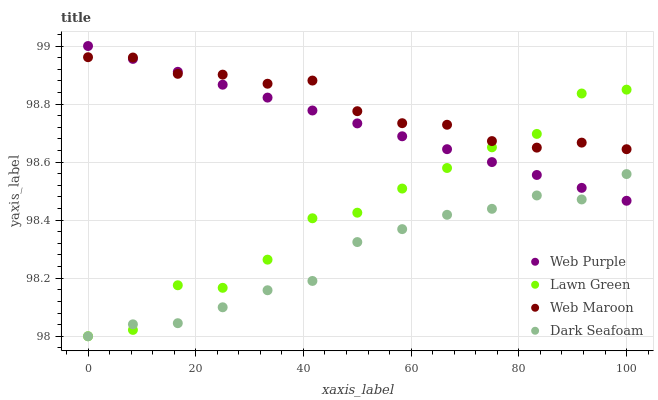Does Dark Seafoam have the minimum area under the curve?
Answer yes or no. Yes. Does Web Maroon have the maximum area under the curve?
Answer yes or no. Yes. Does Web Purple have the minimum area under the curve?
Answer yes or no. No. Does Web Purple have the maximum area under the curve?
Answer yes or no. No. Is Web Purple the smoothest?
Answer yes or no. Yes. Is Lawn Green the roughest?
Answer yes or no. Yes. Is Web Maroon the smoothest?
Answer yes or no. No. Is Web Maroon the roughest?
Answer yes or no. No. Does Lawn Green have the lowest value?
Answer yes or no. Yes. Does Web Purple have the lowest value?
Answer yes or no. No. Does Web Purple have the highest value?
Answer yes or no. Yes. Does Web Maroon have the highest value?
Answer yes or no. No. Is Dark Seafoam less than Web Maroon?
Answer yes or no. Yes. Is Web Maroon greater than Dark Seafoam?
Answer yes or no. Yes. Does Lawn Green intersect Web Purple?
Answer yes or no. Yes. Is Lawn Green less than Web Purple?
Answer yes or no. No. Is Lawn Green greater than Web Purple?
Answer yes or no. No. Does Dark Seafoam intersect Web Maroon?
Answer yes or no. No. 